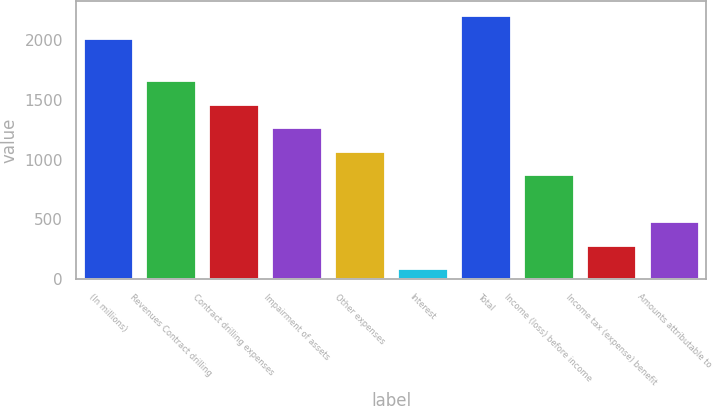Convert chart. <chart><loc_0><loc_0><loc_500><loc_500><bar_chart><fcel>(In millions)<fcel>Revenues Contract drilling<fcel>Contract drilling expenses<fcel>Impairment of assets<fcel>Other expenses<fcel>Interest<fcel>Total<fcel>Income (loss) before income<fcel>Income tax (expense) benefit<fcel>Amounts attributable to<nl><fcel>2016<fcel>1666<fcel>1469<fcel>1272<fcel>1075<fcel>90<fcel>2213<fcel>878<fcel>287<fcel>484<nl></chart> 